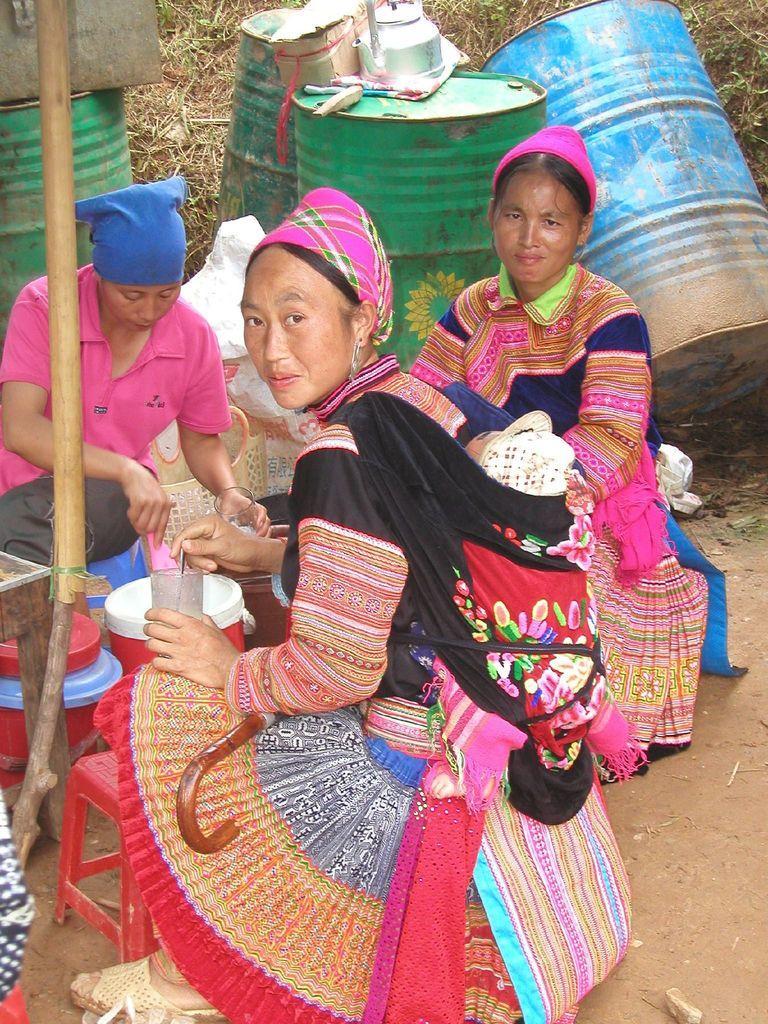How would you summarize this image in a sentence or two? In this image we can see persons sitting on the chairs stools. In the background there are bins, kettle and lawn straw. 